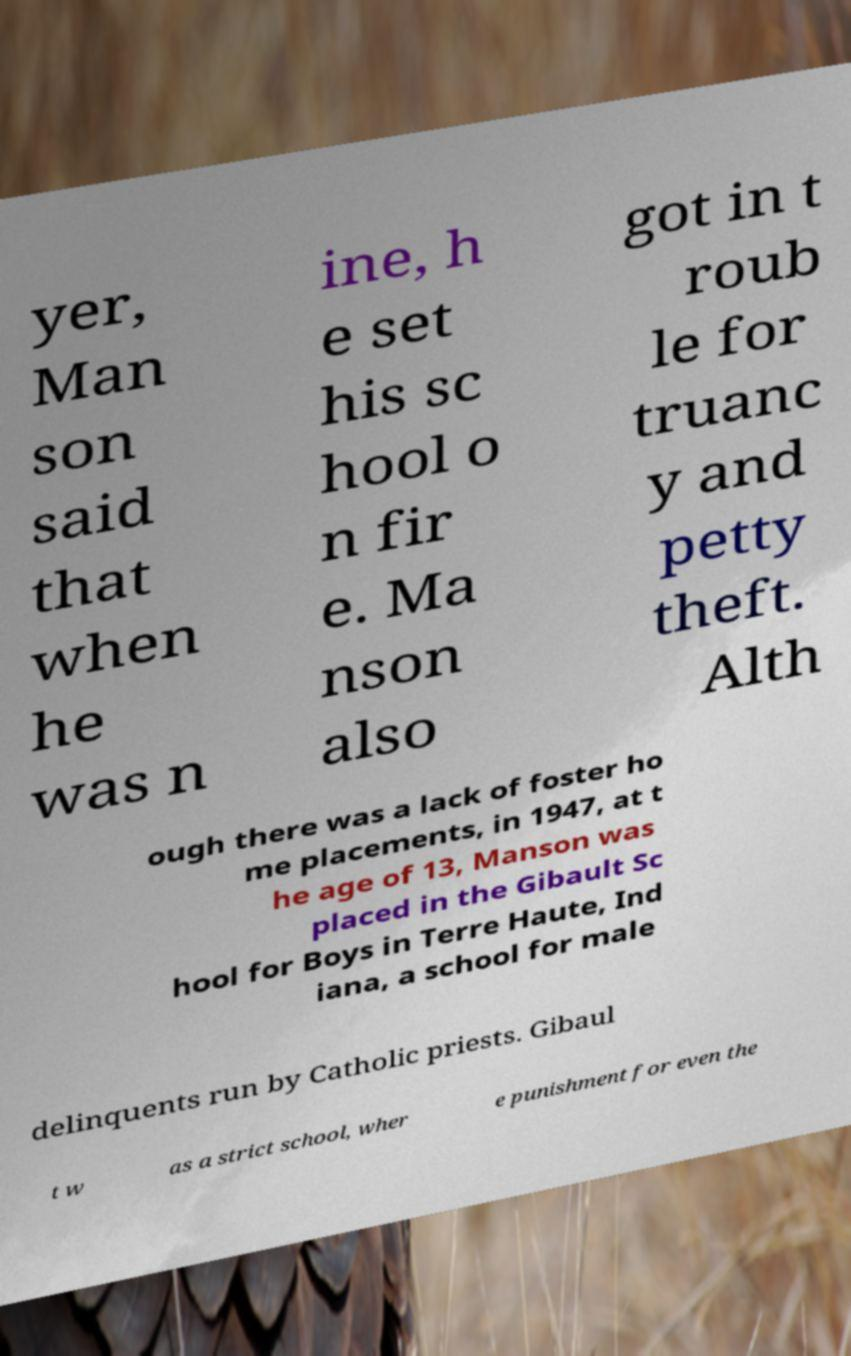Please identify and transcribe the text found in this image. yer, Man son said that when he was n ine, h e set his sc hool o n fir e. Ma nson also got in t roub le for truanc y and petty theft. Alth ough there was a lack of foster ho me placements, in 1947, at t he age of 13, Manson was placed in the Gibault Sc hool for Boys in Terre Haute, Ind iana, a school for male delinquents run by Catholic priests. Gibaul t w as a strict school, wher e punishment for even the 